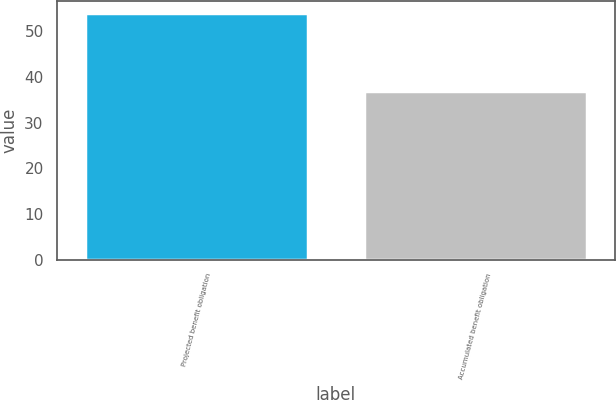Convert chart to OTSL. <chart><loc_0><loc_0><loc_500><loc_500><bar_chart><fcel>Projected benefit obligation<fcel>Accumulated benefit obligation<nl><fcel>54<fcel>37<nl></chart> 